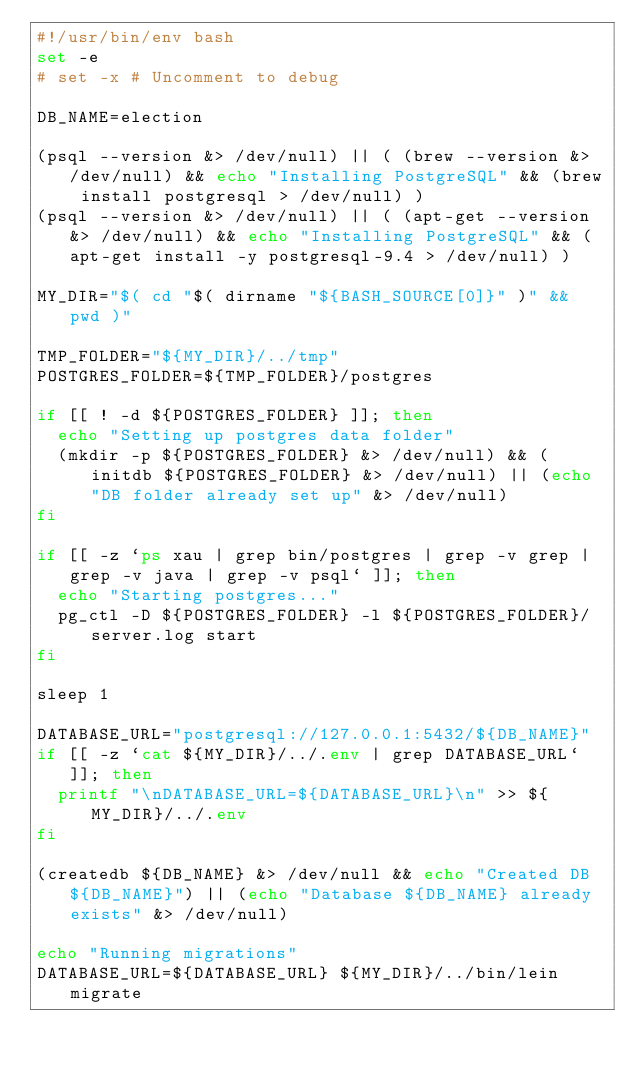Convert code to text. <code><loc_0><loc_0><loc_500><loc_500><_Bash_>#!/usr/bin/env bash
set -e
# set -x # Uncomment to debug

DB_NAME=election

(psql --version &> /dev/null) || ( (brew --version &> /dev/null) && echo "Installing PostgreSQL" && (brew install postgresql > /dev/null) )
(psql --version &> /dev/null) || ( (apt-get --version &> /dev/null) && echo "Installing PostgreSQL" && (apt-get install -y postgresql-9.4 > /dev/null) )

MY_DIR="$( cd "$( dirname "${BASH_SOURCE[0]}" )" && pwd )"

TMP_FOLDER="${MY_DIR}/../tmp"
POSTGRES_FOLDER=${TMP_FOLDER}/postgres

if [[ ! -d ${POSTGRES_FOLDER} ]]; then
  echo "Setting up postgres data folder"
  (mkdir -p ${POSTGRES_FOLDER} &> /dev/null) && (initdb ${POSTGRES_FOLDER} &> /dev/null) || (echo "DB folder already set up" &> /dev/null)
fi

if [[ -z `ps xau | grep bin/postgres | grep -v grep | grep -v java | grep -v psql` ]]; then
  echo "Starting postgres..."
  pg_ctl -D ${POSTGRES_FOLDER} -l ${POSTGRES_FOLDER}/server.log start
fi

sleep 1

DATABASE_URL="postgresql://127.0.0.1:5432/${DB_NAME}"
if [[ -z `cat ${MY_DIR}/../.env | grep DATABASE_URL` ]]; then
  printf "\nDATABASE_URL=${DATABASE_URL}\n" >> ${MY_DIR}/../.env
fi

(createdb ${DB_NAME} &> /dev/null && echo "Created DB ${DB_NAME}") || (echo "Database ${DB_NAME} already exists" &> /dev/null)

echo "Running migrations"
DATABASE_URL=${DATABASE_URL} ${MY_DIR}/../bin/lein migrate
</code> 